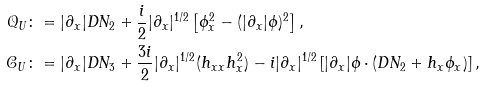Convert formula to latex. <formula><loc_0><loc_0><loc_500><loc_500>\mathcal { Q } _ { U } & \colon = | \partial _ { x } | D N _ { 2 } + \frac { i } { 2 } | \partial _ { x } | ^ { 1 / 2 } \left [ \phi _ { x } ^ { 2 } - ( | \partial _ { x } | \phi ) ^ { 2 } \right ] , \\ \mathcal { C } _ { U } & \colon = | \partial _ { x } | D N _ { 3 } + \frac { 3 i } { 2 } | \partial _ { x } | ^ { 1 / 2 } ( h _ { x x } h _ { x } ^ { 2 } ) - i | \partial _ { x } | ^ { 1 / 2 } \left [ | \partial _ { x } | \phi \cdot ( D N _ { 2 } + h _ { x } \phi _ { x } ) \right ] ,</formula> 